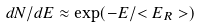<formula> <loc_0><loc_0><loc_500><loc_500>d N / d E \approx \exp ( - E / < E _ { R } > )</formula> 